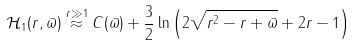Convert formula to latex. <formula><loc_0><loc_0><loc_500><loc_500>\mathcal { H } _ { 1 } ( r , \varpi ) \stackrel { r \gg 1 } { \approx } C ( \varpi ) + \frac { 3 } { 2 } \ln \left ( 2 \sqrt { r ^ { 2 } - r + \varpi } + 2 r - 1 \right )</formula> 